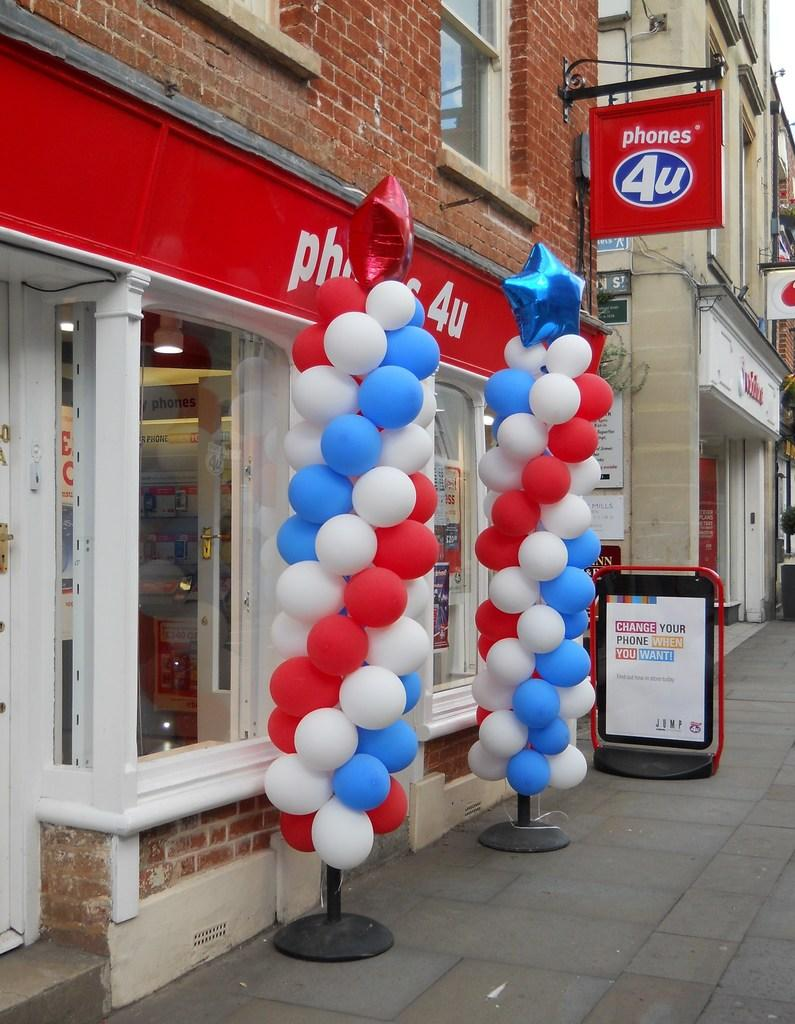What type of structures can be seen in the image? There are buildings in the image. What can be found on the sidewalk in the image? There are advertisement boards on the sidewalk. Can you describe an advertisement board that is not on the sidewalk? There is an advertisement board hanging on a wall. What decorative items are present in the image? There are balloons on a stand in the image. How many babies are being fed beef in the image? There are no babies or beef present in the image. What is the limit of the image's capacity to show more objects? The image's capacity to show more objects is not limited; it can display as many objects as are present within its frame. 